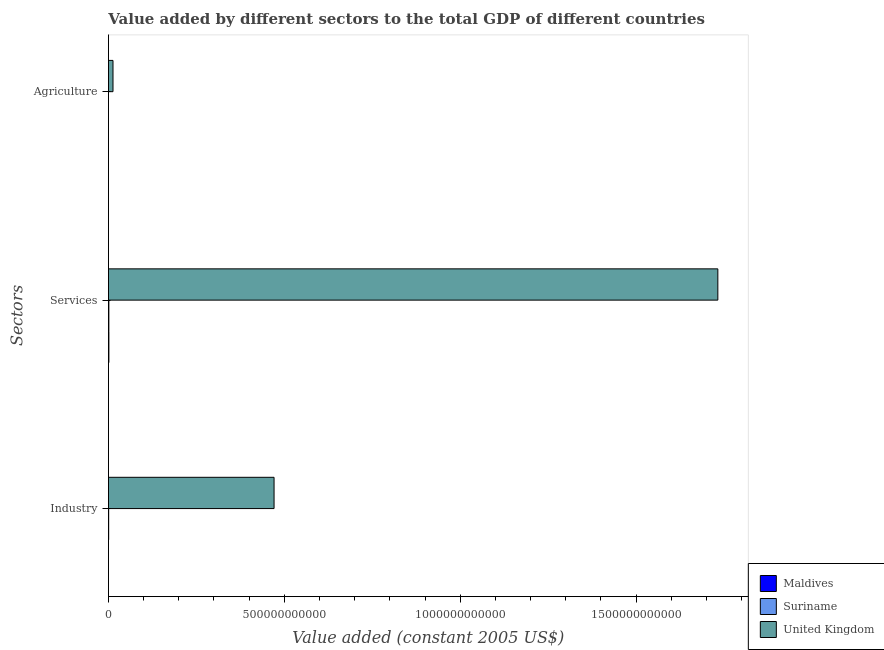How many different coloured bars are there?
Ensure brevity in your answer.  3. How many groups of bars are there?
Keep it short and to the point. 3. How many bars are there on the 1st tick from the bottom?
Ensure brevity in your answer.  3. What is the label of the 2nd group of bars from the top?
Provide a short and direct response. Services. What is the value added by agricultural sector in United Kingdom?
Your answer should be compact. 1.30e+1. Across all countries, what is the maximum value added by services?
Your answer should be very brief. 1.73e+12. Across all countries, what is the minimum value added by industrial sector?
Keep it short and to the point. 1.73e+08. In which country was the value added by services maximum?
Make the answer very short. United Kingdom. In which country was the value added by industrial sector minimum?
Keep it short and to the point. Maldives. What is the total value added by agricultural sector in the graph?
Give a very brief answer. 1.32e+1. What is the difference between the value added by agricultural sector in Suriname and that in Maldives?
Offer a very short reply. 5.31e+07. What is the difference between the value added by agricultural sector in United Kingdom and the value added by industrial sector in Suriname?
Your answer should be very brief. 1.23e+1. What is the average value added by industrial sector per country?
Ensure brevity in your answer.  1.57e+11. What is the difference between the value added by services and value added by agricultural sector in Suriname?
Keep it short and to the point. 1.08e+09. What is the ratio of the value added by services in United Kingdom to that in Maldives?
Your answer should be very brief. 1344.24. What is the difference between the highest and the second highest value added by agricultural sector?
Offer a very short reply. 1.29e+1. What is the difference between the highest and the lowest value added by industrial sector?
Keep it short and to the point. 4.71e+11. Is the sum of the value added by services in Maldives and Suriname greater than the maximum value added by industrial sector across all countries?
Keep it short and to the point. No. What does the 2nd bar from the top in Industry represents?
Give a very brief answer. Suriname. What does the 1st bar from the bottom in Services represents?
Make the answer very short. Maldives. Is it the case that in every country, the sum of the value added by industrial sector and value added by services is greater than the value added by agricultural sector?
Ensure brevity in your answer.  Yes. How many bars are there?
Your answer should be very brief. 9. Are all the bars in the graph horizontal?
Offer a very short reply. Yes. How many countries are there in the graph?
Your response must be concise. 3. What is the difference between two consecutive major ticks on the X-axis?
Your answer should be compact. 5.00e+11. Does the graph contain grids?
Offer a very short reply. No. How many legend labels are there?
Offer a terse response. 3. What is the title of the graph?
Offer a terse response. Value added by different sectors to the total GDP of different countries. Does "Belarus" appear as one of the legend labels in the graph?
Give a very brief answer. No. What is the label or title of the X-axis?
Offer a very short reply. Value added (constant 2005 US$). What is the label or title of the Y-axis?
Give a very brief answer. Sectors. What is the Value added (constant 2005 US$) in Maldives in Industry?
Offer a terse response. 1.73e+08. What is the Value added (constant 2005 US$) of Suriname in Industry?
Make the answer very short. 6.85e+08. What is the Value added (constant 2005 US$) in United Kingdom in Industry?
Provide a short and direct response. 4.71e+11. What is the Value added (constant 2005 US$) in Maldives in Services?
Offer a very short reply. 1.29e+09. What is the Value added (constant 2005 US$) in Suriname in Services?
Make the answer very short. 1.20e+09. What is the Value added (constant 2005 US$) of United Kingdom in Services?
Your answer should be compact. 1.73e+12. What is the Value added (constant 2005 US$) in Maldives in Agriculture?
Your answer should be very brief. 6.67e+07. What is the Value added (constant 2005 US$) of Suriname in Agriculture?
Your response must be concise. 1.20e+08. What is the Value added (constant 2005 US$) in United Kingdom in Agriculture?
Make the answer very short. 1.30e+1. Across all Sectors, what is the maximum Value added (constant 2005 US$) in Maldives?
Make the answer very short. 1.29e+09. Across all Sectors, what is the maximum Value added (constant 2005 US$) of Suriname?
Provide a short and direct response. 1.20e+09. Across all Sectors, what is the maximum Value added (constant 2005 US$) in United Kingdom?
Make the answer very short. 1.73e+12. Across all Sectors, what is the minimum Value added (constant 2005 US$) in Maldives?
Make the answer very short. 6.67e+07. Across all Sectors, what is the minimum Value added (constant 2005 US$) in Suriname?
Provide a short and direct response. 1.20e+08. Across all Sectors, what is the minimum Value added (constant 2005 US$) in United Kingdom?
Offer a terse response. 1.30e+1. What is the total Value added (constant 2005 US$) of Maldives in the graph?
Keep it short and to the point. 1.53e+09. What is the total Value added (constant 2005 US$) in Suriname in the graph?
Your response must be concise. 2.01e+09. What is the total Value added (constant 2005 US$) in United Kingdom in the graph?
Your response must be concise. 2.22e+12. What is the difference between the Value added (constant 2005 US$) in Maldives in Industry and that in Services?
Offer a terse response. -1.12e+09. What is the difference between the Value added (constant 2005 US$) in Suriname in Industry and that in Services?
Give a very brief answer. -5.20e+08. What is the difference between the Value added (constant 2005 US$) in United Kingdom in Industry and that in Services?
Make the answer very short. -1.26e+12. What is the difference between the Value added (constant 2005 US$) of Maldives in Industry and that in Agriculture?
Offer a terse response. 1.07e+08. What is the difference between the Value added (constant 2005 US$) in Suriname in Industry and that in Agriculture?
Your answer should be very brief. 5.65e+08. What is the difference between the Value added (constant 2005 US$) in United Kingdom in Industry and that in Agriculture?
Ensure brevity in your answer.  4.58e+11. What is the difference between the Value added (constant 2005 US$) of Maldives in Services and that in Agriculture?
Ensure brevity in your answer.  1.22e+09. What is the difference between the Value added (constant 2005 US$) in Suriname in Services and that in Agriculture?
Offer a terse response. 1.08e+09. What is the difference between the Value added (constant 2005 US$) in United Kingdom in Services and that in Agriculture?
Your answer should be compact. 1.72e+12. What is the difference between the Value added (constant 2005 US$) in Maldives in Industry and the Value added (constant 2005 US$) in Suriname in Services?
Your answer should be very brief. -1.03e+09. What is the difference between the Value added (constant 2005 US$) of Maldives in Industry and the Value added (constant 2005 US$) of United Kingdom in Services?
Provide a short and direct response. -1.73e+12. What is the difference between the Value added (constant 2005 US$) of Suriname in Industry and the Value added (constant 2005 US$) of United Kingdom in Services?
Provide a short and direct response. -1.73e+12. What is the difference between the Value added (constant 2005 US$) in Maldives in Industry and the Value added (constant 2005 US$) in Suriname in Agriculture?
Ensure brevity in your answer.  5.35e+07. What is the difference between the Value added (constant 2005 US$) of Maldives in Industry and the Value added (constant 2005 US$) of United Kingdom in Agriculture?
Keep it short and to the point. -1.28e+1. What is the difference between the Value added (constant 2005 US$) in Suriname in Industry and the Value added (constant 2005 US$) in United Kingdom in Agriculture?
Offer a terse response. -1.23e+1. What is the difference between the Value added (constant 2005 US$) in Maldives in Services and the Value added (constant 2005 US$) in Suriname in Agriculture?
Offer a terse response. 1.17e+09. What is the difference between the Value added (constant 2005 US$) in Maldives in Services and the Value added (constant 2005 US$) in United Kingdom in Agriculture?
Give a very brief answer. -1.17e+1. What is the difference between the Value added (constant 2005 US$) in Suriname in Services and the Value added (constant 2005 US$) in United Kingdom in Agriculture?
Keep it short and to the point. -1.18e+1. What is the average Value added (constant 2005 US$) of Maldives per Sectors?
Provide a short and direct response. 5.10e+08. What is the average Value added (constant 2005 US$) in Suriname per Sectors?
Your answer should be very brief. 6.70e+08. What is the average Value added (constant 2005 US$) in United Kingdom per Sectors?
Keep it short and to the point. 7.39e+11. What is the difference between the Value added (constant 2005 US$) in Maldives and Value added (constant 2005 US$) in Suriname in Industry?
Give a very brief answer. -5.12e+08. What is the difference between the Value added (constant 2005 US$) of Maldives and Value added (constant 2005 US$) of United Kingdom in Industry?
Your answer should be compact. -4.71e+11. What is the difference between the Value added (constant 2005 US$) in Suriname and Value added (constant 2005 US$) in United Kingdom in Industry?
Keep it short and to the point. -4.70e+11. What is the difference between the Value added (constant 2005 US$) in Maldives and Value added (constant 2005 US$) in Suriname in Services?
Your answer should be compact. 8.39e+07. What is the difference between the Value added (constant 2005 US$) of Maldives and Value added (constant 2005 US$) of United Kingdom in Services?
Your response must be concise. -1.73e+12. What is the difference between the Value added (constant 2005 US$) in Suriname and Value added (constant 2005 US$) in United Kingdom in Services?
Provide a short and direct response. -1.73e+12. What is the difference between the Value added (constant 2005 US$) in Maldives and Value added (constant 2005 US$) in Suriname in Agriculture?
Keep it short and to the point. -5.31e+07. What is the difference between the Value added (constant 2005 US$) of Maldives and Value added (constant 2005 US$) of United Kingdom in Agriculture?
Your answer should be very brief. -1.29e+1. What is the difference between the Value added (constant 2005 US$) of Suriname and Value added (constant 2005 US$) of United Kingdom in Agriculture?
Offer a very short reply. -1.29e+1. What is the ratio of the Value added (constant 2005 US$) in Maldives in Industry to that in Services?
Provide a succinct answer. 0.13. What is the ratio of the Value added (constant 2005 US$) of Suriname in Industry to that in Services?
Make the answer very short. 0.57. What is the ratio of the Value added (constant 2005 US$) in United Kingdom in Industry to that in Services?
Keep it short and to the point. 0.27. What is the ratio of the Value added (constant 2005 US$) in Maldives in Industry to that in Agriculture?
Keep it short and to the point. 2.6. What is the ratio of the Value added (constant 2005 US$) of Suriname in Industry to that in Agriculture?
Your response must be concise. 5.72. What is the ratio of the Value added (constant 2005 US$) of United Kingdom in Industry to that in Agriculture?
Your response must be concise. 36.28. What is the ratio of the Value added (constant 2005 US$) of Maldives in Services to that in Agriculture?
Your response must be concise. 19.31. What is the ratio of the Value added (constant 2005 US$) of Suriname in Services to that in Agriculture?
Ensure brevity in your answer.  10.05. What is the ratio of the Value added (constant 2005 US$) of United Kingdom in Services to that in Agriculture?
Provide a short and direct response. 133.5. What is the difference between the highest and the second highest Value added (constant 2005 US$) of Maldives?
Provide a short and direct response. 1.12e+09. What is the difference between the highest and the second highest Value added (constant 2005 US$) of Suriname?
Your answer should be very brief. 5.20e+08. What is the difference between the highest and the second highest Value added (constant 2005 US$) in United Kingdom?
Make the answer very short. 1.26e+12. What is the difference between the highest and the lowest Value added (constant 2005 US$) of Maldives?
Ensure brevity in your answer.  1.22e+09. What is the difference between the highest and the lowest Value added (constant 2005 US$) of Suriname?
Your answer should be compact. 1.08e+09. What is the difference between the highest and the lowest Value added (constant 2005 US$) of United Kingdom?
Ensure brevity in your answer.  1.72e+12. 